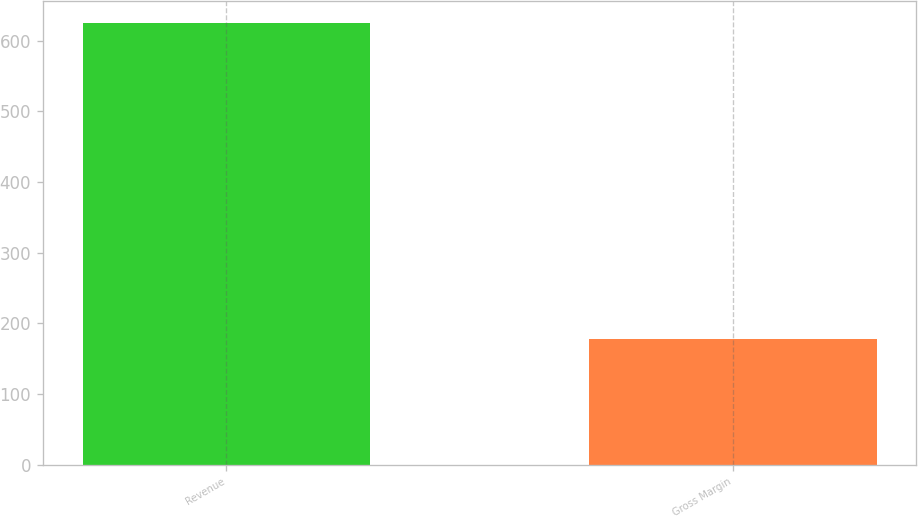Convert chart. <chart><loc_0><loc_0><loc_500><loc_500><bar_chart><fcel>Revenue<fcel>Gross Margin<nl><fcel>625<fcel>178<nl></chart> 